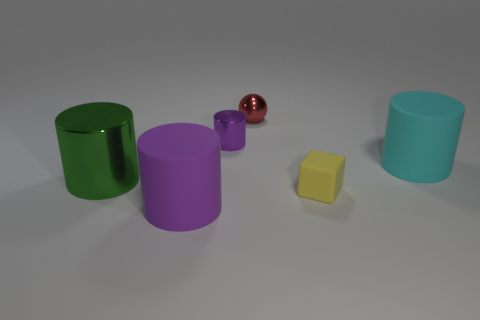Are there any other things that have the same shape as the tiny red thing?
Ensure brevity in your answer.  No. What number of blocks have the same color as the small ball?
Make the answer very short. 0. There is a metal cylinder in front of the tiny purple metal cylinder; are there any green objects that are right of it?
Provide a short and direct response. No. Does the rubber object that is on the left side of the red metallic ball have the same color as the matte cylinder right of the tiny metallic cylinder?
Ensure brevity in your answer.  No. There is a metal cylinder that is the same size as the purple rubber cylinder; what color is it?
Your response must be concise. Green. Is the number of small spheres that are right of the tiny red object the same as the number of small purple objects to the right of the small yellow rubber thing?
Offer a terse response. Yes. What material is the object that is on the left side of the large matte cylinder in front of the green metallic cylinder?
Offer a very short reply. Metal. How many things are either metallic objects or green matte cubes?
Your response must be concise. 3. What size is the matte thing that is the same color as the tiny cylinder?
Give a very brief answer. Large. Are there fewer green metal cubes than purple matte things?
Your answer should be compact. Yes. 